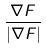Convert formula to latex. <formula><loc_0><loc_0><loc_500><loc_500>\frac { \nabla F } { | \nabla F | }</formula> 